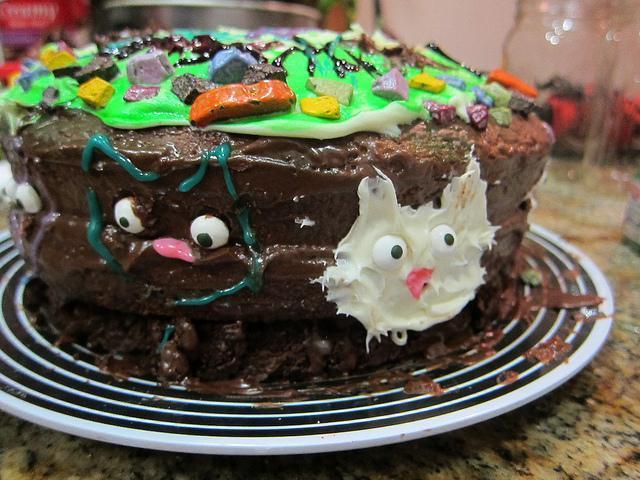How many people are in the photo?
Give a very brief answer. 0. 